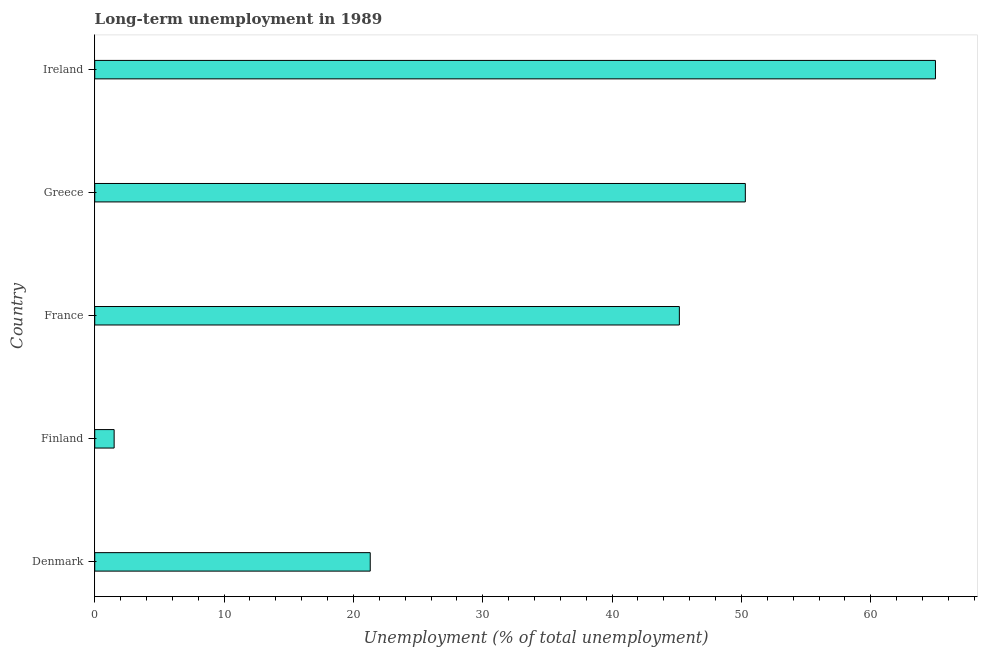Does the graph contain any zero values?
Give a very brief answer. No. What is the title of the graph?
Provide a succinct answer. Long-term unemployment in 1989. What is the label or title of the X-axis?
Your answer should be compact. Unemployment (% of total unemployment). What is the long-term unemployment in Denmark?
Your answer should be compact. 21.3. Across all countries, what is the minimum long-term unemployment?
Ensure brevity in your answer.  1.5. In which country was the long-term unemployment maximum?
Provide a succinct answer. Ireland. In which country was the long-term unemployment minimum?
Your answer should be very brief. Finland. What is the sum of the long-term unemployment?
Make the answer very short. 183.3. What is the average long-term unemployment per country?
Your response must be concise. 36.66. What is the median long-term unemployment?
Provide a short and direct response. 45.2. What is the ratio of the long-term unemployment in France to that in Greece?
Offer a very short reply. 0.9. Is the long-term unemployment in Finland less than that in Greece?
Offer a very short reply. Yes. Is the difference between the long-term unemployment in France and Greece greater than the difference between any two countries?
Provide a succinct answer. No. Is the sum of the long-term unemployment in France and Ireland greater than the maximum long-term unemployment across all countries?
Provide a short and direct response. Yes. What is the difference between the highest and the lowest long-term unemployment?
Offer a terse response. 63.5. In how many countries, is the long-term unemployment greater than the average long-term unemployment taken over all countries?
Give a very brief answer. 3. Are the values on the major ticks of X-axis written in scientific E-notation?
Offer a very short reply. No. What is the Unemployment (% of total unemployment) of Denmark?
Offer a very short reply. 21.3. What is the Unemployment (% of total unemployment) in Finland?
Keep it short and to the point. 1.5. What is the Unemployment (% of total unemployment) in France?
Your response must be concise. 45.2. What is the Unemployment (% of total unemployment) of Greece?
Your response must be concise. 50.3. What is the difference between the Unemployment (% of total unemployment) in Denmark and Finland?
Provide a short and direct response. 19.8. What is the difference between the Unemployment (% of total unemployment) in Denmark and France?
Ensure brevity in your answer.  -23.9. What is the difference between the Unemployment (% of total unemployment) in Denmark and Ireland?
Make the answer very short. -43.7. What is the difference between the Unemployment (% of total unemployment) in Finland and France?
Offer a terse response. -43.7. What is the difference between the Unemployment (% of total unemployment) in Finland and Greece?
Offer a very short reply. -48.8. What is the difference between the Unemployment (% of total unemployment) in Finland and Ireland?
Keep it short and to the point. -63.5. What is the difference between the Unemployment (% of total unemployment) in France and Ireland?
Ensure brevity in your answer.  -19.8. What is the difference between the Unemployment (% of total unemployment) in Greece and Ireland?
Provide a short and direct response. -14.7. What is the ratio of the Unemployment (% of total unemployment) in Denmark to that in Finland?
Your response must be concise. 14.2. What is the ratio of the Unemployment (% of total unemployment) in Denmark to that in France?
Ensure brevity in your answer.  0.47. What is the ratio of the Unemployment (% of total unemployment) in Denmark to that in Greece?
Your answer should be compact. 0.42. What is the ratio of the Unemployment (% of total unemployment) in Denmark to that in Ireland?
Ensure brevity in your answer.  0.33. What is the ratio of the Unemployment (% of total unemployment) in Finland to that in France?
Keep it short and to the point. 0.03. What is the ratio of the Unemployment (% of total unemployment) in Finland to that in Greece?
Your response must be concise. 0.03. What is the ratio of the Unemployment (% of total unemployment) in Finland to that in Ireland?
Provide a short and direct response. 0.02. What is the ratio of the Unemployment (% of total unemployment) in France to that in Greece?
Offer a very short reply. 0.9. What is the ratio of the Unemployment (% of total unemployment) in France to that in Ireland?
Provide a short and direct response. 0.69. What is the ratio of the Unemployment (% of total unemployment) in Greece to that in Ireland?
Offer a terse response. 0.77. 